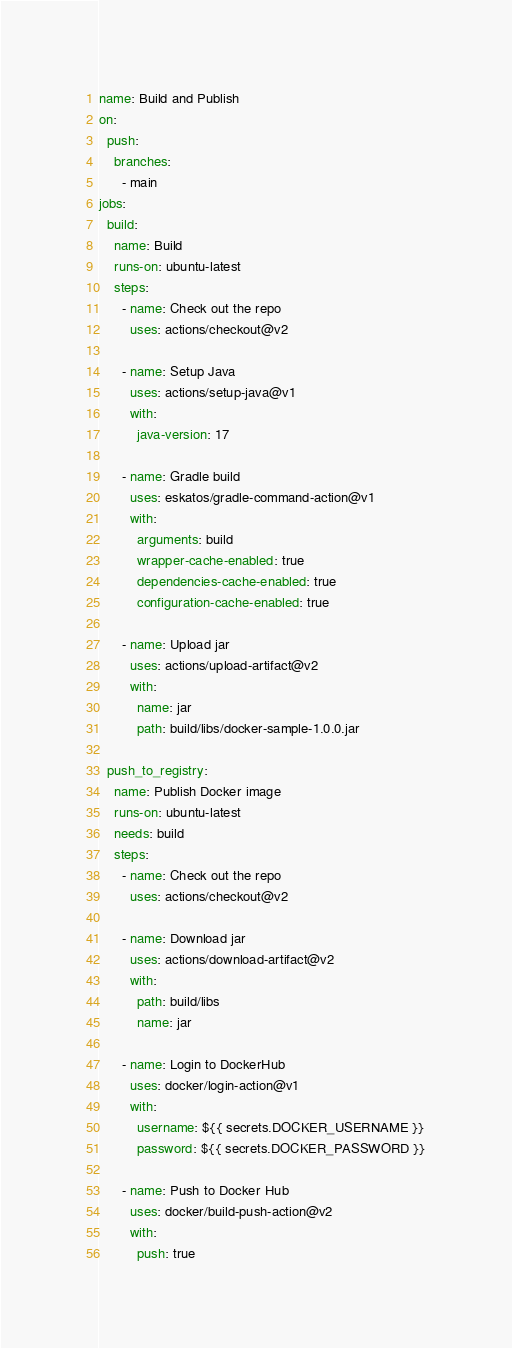<code> <loc_0><loc_0><loc_500><loc_500><_YAML_>name: Build and Publish
on:
  push:
    branches:
      - main
jobs:
  build:
    name: Build
    runs-on: ubuntu-latest
    steps:
      - name: Check out the repo
        uses: actions/checkout@v2

      - name: Setup Java
        uses: actions/setup-java@v1
        with:
          java-version: 17

      - name: Gradle build
        uses: eskatos/gradle-command-action@v1
        with:
          arguments: build
          wrapper-cache-enabled: true
          dependencies-cache-enabled: true
          configuration-cache-enabled: true

      - name: Upload jar
        uses: actions/upload-artifact@v2
        with:
          name: jar
          path: build/libs/docker-sample-1.0.0.jar

  push_to_registry:
    name: Publish Docker image
    runs-on: ubuntu-latest
    needs: build
    steps:
      - name: Check out the repo
        uses: actions/checkout@v2

      - name: Download jar
        uses: actions/download-artifact@v2
        with:
          path: build/libs
          name: jar

      - name: Login to DockerHub
        uses: docker/login-action@v1
        with:
          username: ${{ secrets.DOCKER_USERNAME }}
          password: ${{ secrets.DOCKER_PASSWORD }}

      - name: Push to Docker Hub
        uses: docker/build-push-action@v2
        with:
          push: true</code> 